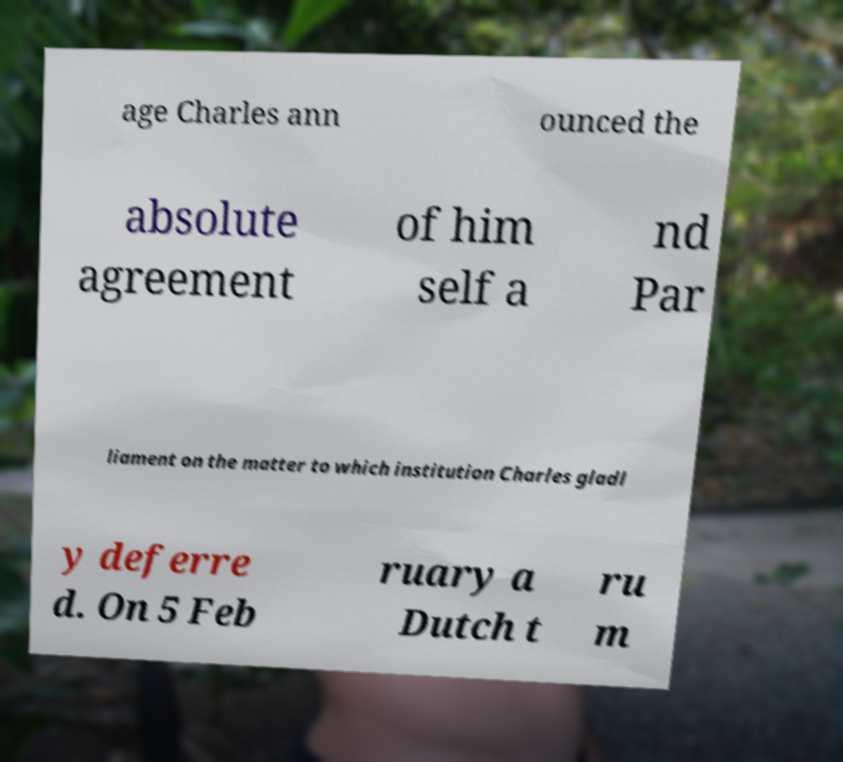Can you accurately transcribe the text from the provided image for me? age Charles ann ounced the absolute agreement of him self a nd Par liament on the matter to which institution Charles gladl y deferre d. On 5 Feb ruary a Dutch t ru m 